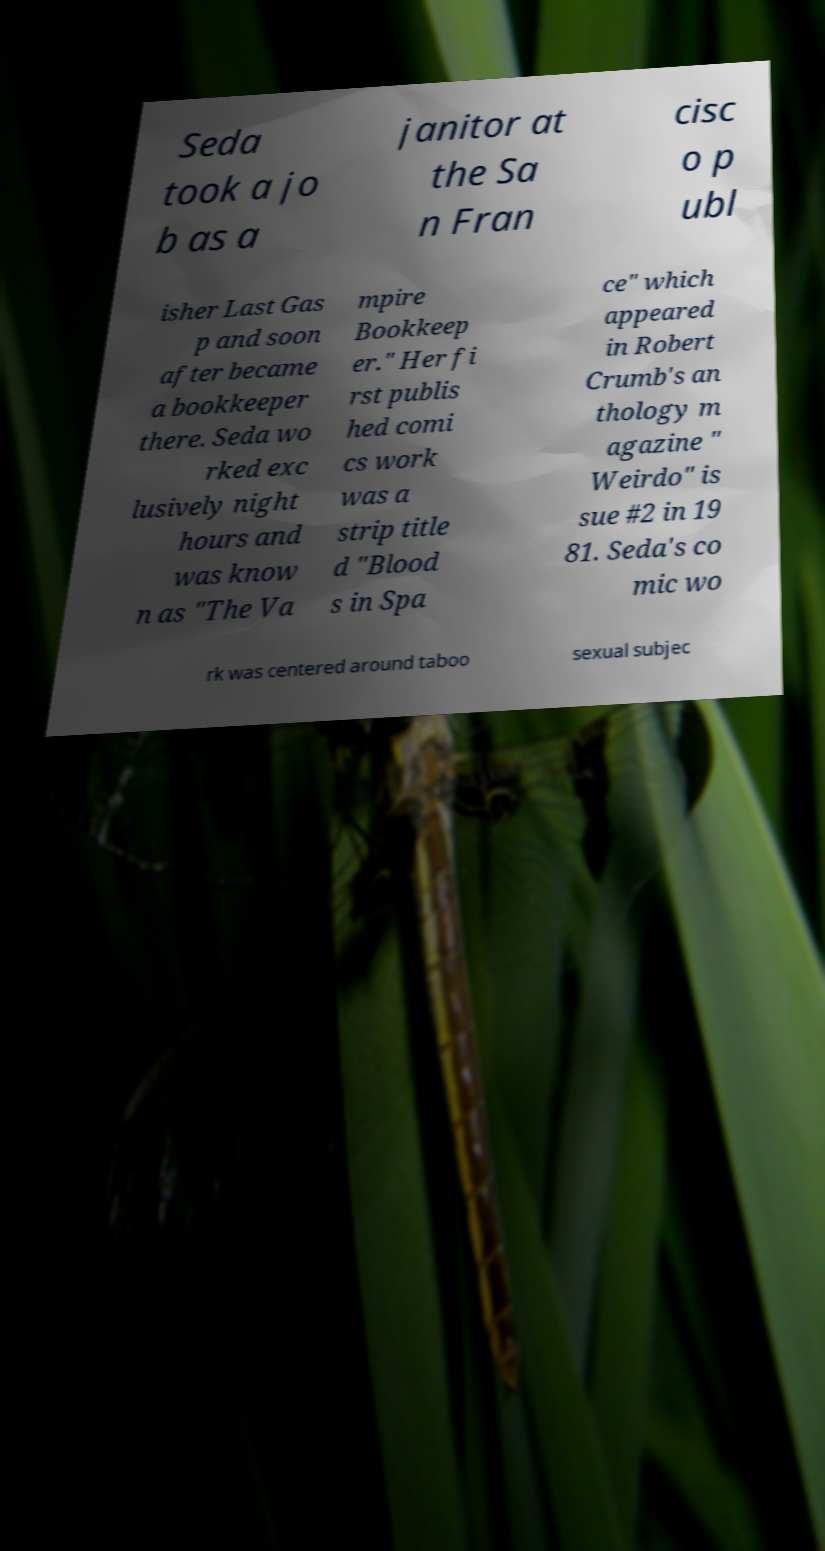I need the written content from this picture converted into text. Can you do that? Seda took a jo b as a janitor at the Sa n Fran cisc o p ubl isher Last Gas p and soon after became a bookkeeper there. Seda wo rked exc lusively night hours and was know n as "The Va mpire Bookkeep er." Her fi rst publis hed comi cs work was a strip title d "Blood s in Spa ce" which appeared in Robert Crumb's an thology m agazine " Weirdo" is sue #2 in 19 81. Seda's co mic wo rk was centered around taboo sexual subjec 